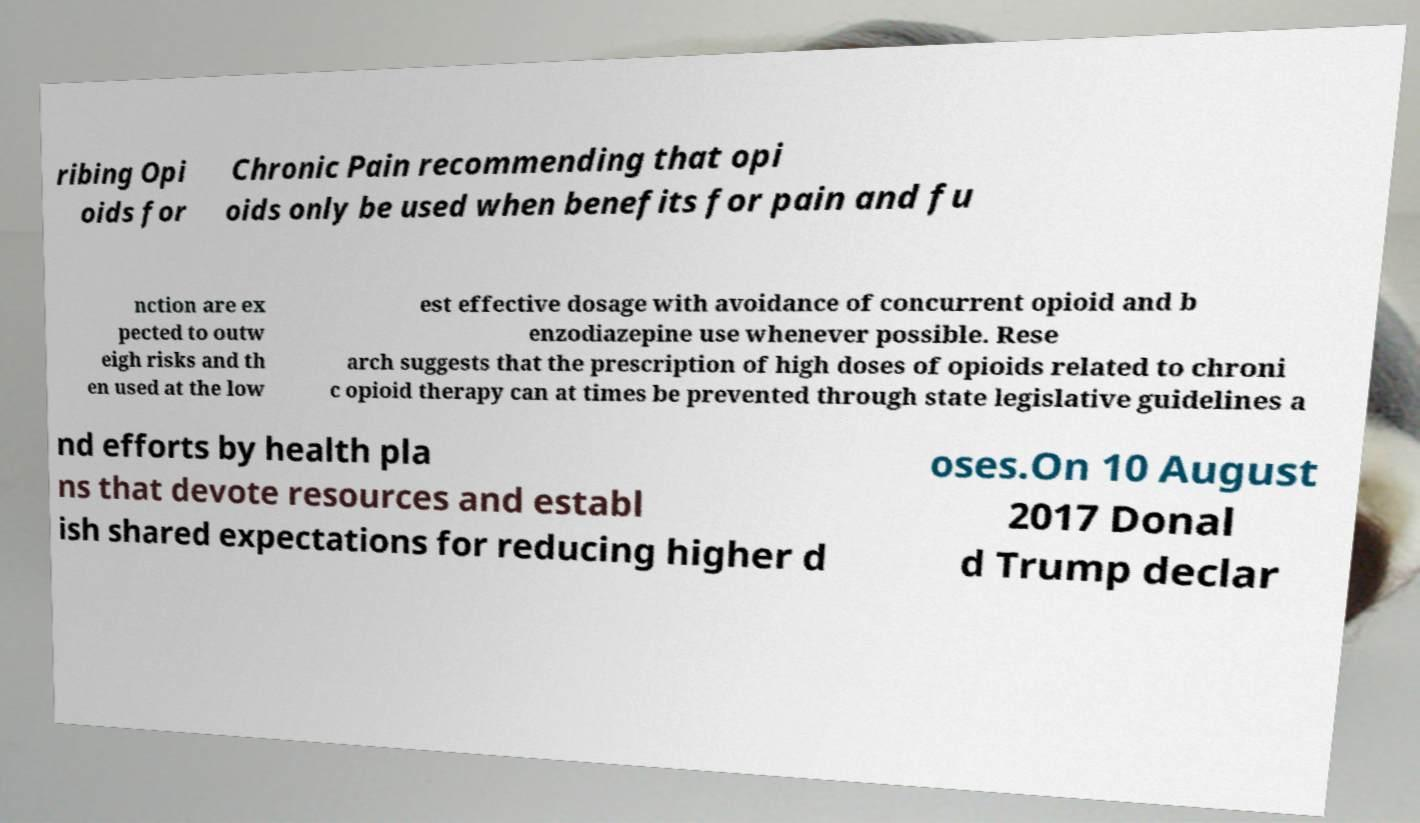Can you read and provide the text displayed in the image?This photo seems to have some interesting text. Can you extract and type it out for me? ribing Opi oids for Chronic Pain recommending that opi oids only be used when benefits for pain and fu nction are ex pected to outw eigh risks and th en used at the low est effective dosage with avoidance of concurrent opioid and b enzodiazepine use whenever possible. Rese arch suggests that the prescription of high doses of opioids related to chroni c opioid therapy can at times be prevented through state legislative guidelines a nd efforts by health pla ns that devote resources and establ ish shared expectations for reducing higher d oses.On 10 August 2017 Donal d Trump declar 